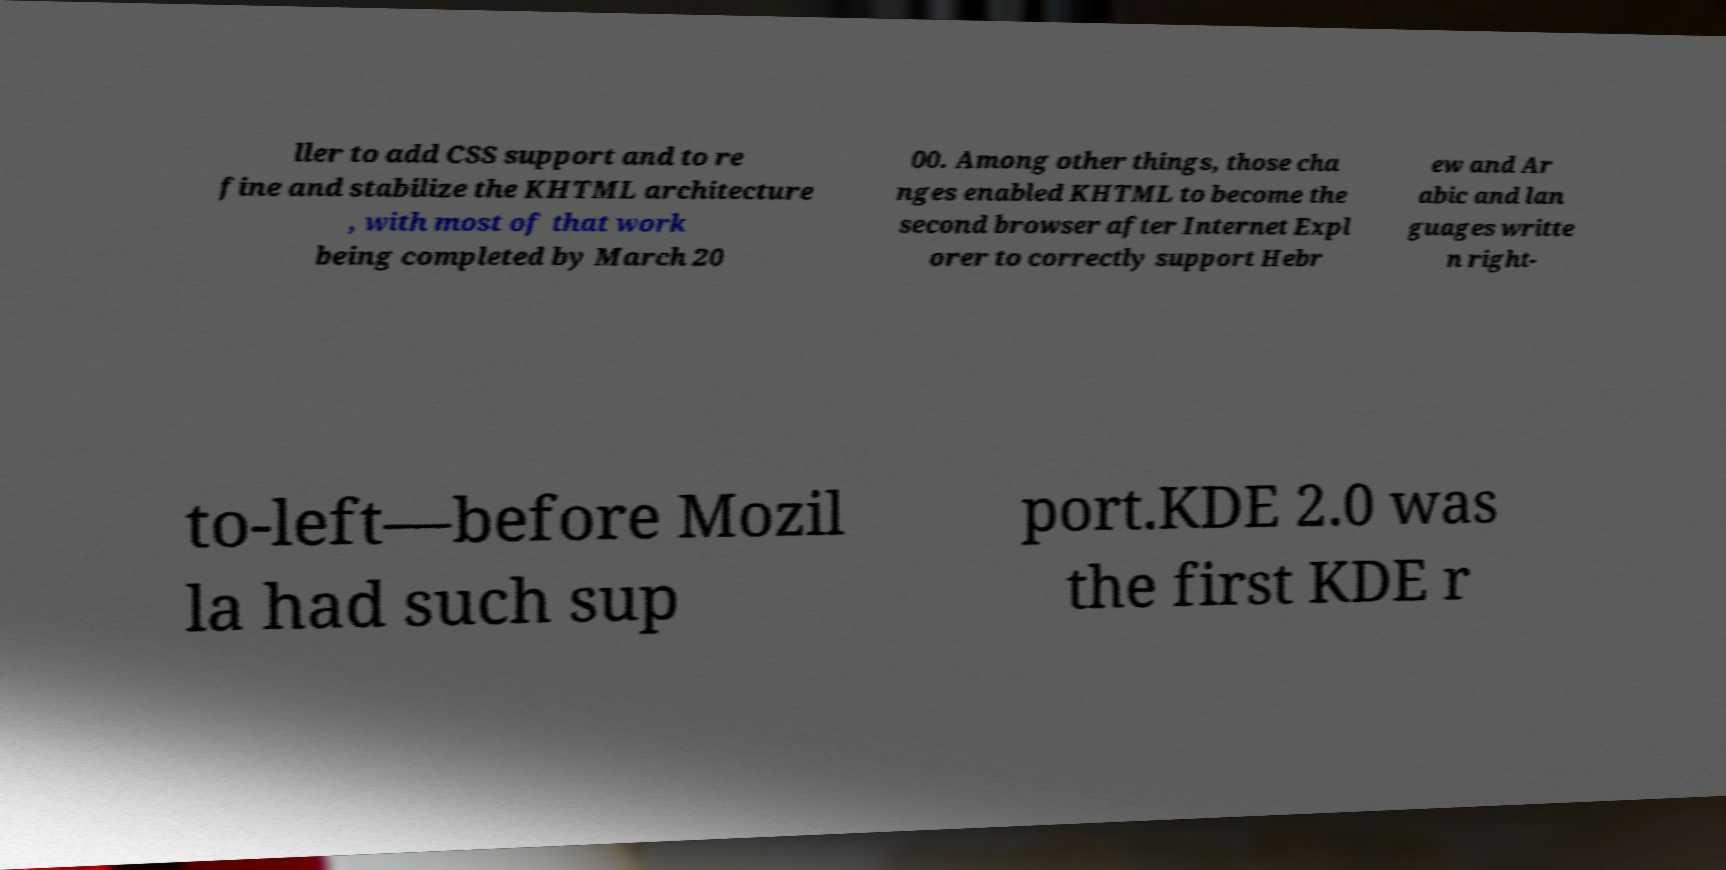What messages or text are displayed in this image? I need them in a readable, typed format. ller to add CSS support and to re fine and stabilize the KHTML architecture , with most of that work being completed by March 20 00. Among other things, those cha nges enabled KHTML to become the second browser after Internet Expl orer to correctly support Hebr ew and Ar abic and lan guages writte n right- to-left—before Mozil la had such sup port.KDE 2.0 was the first KDE r 